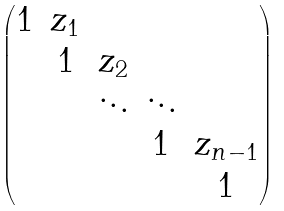Convert formula to latex. <formula><loc_0><loc_0><loc_500><loc_500>\begin{pmatrix} 1 & z _ { 1 } & & & \\ & 1 & z _ { 2 } & & \\ & & \ddots & \ddots & \\ & & & 1 & z _ { n - 1 } \\ & & & & 1 \end{pmatrix}</formula> 